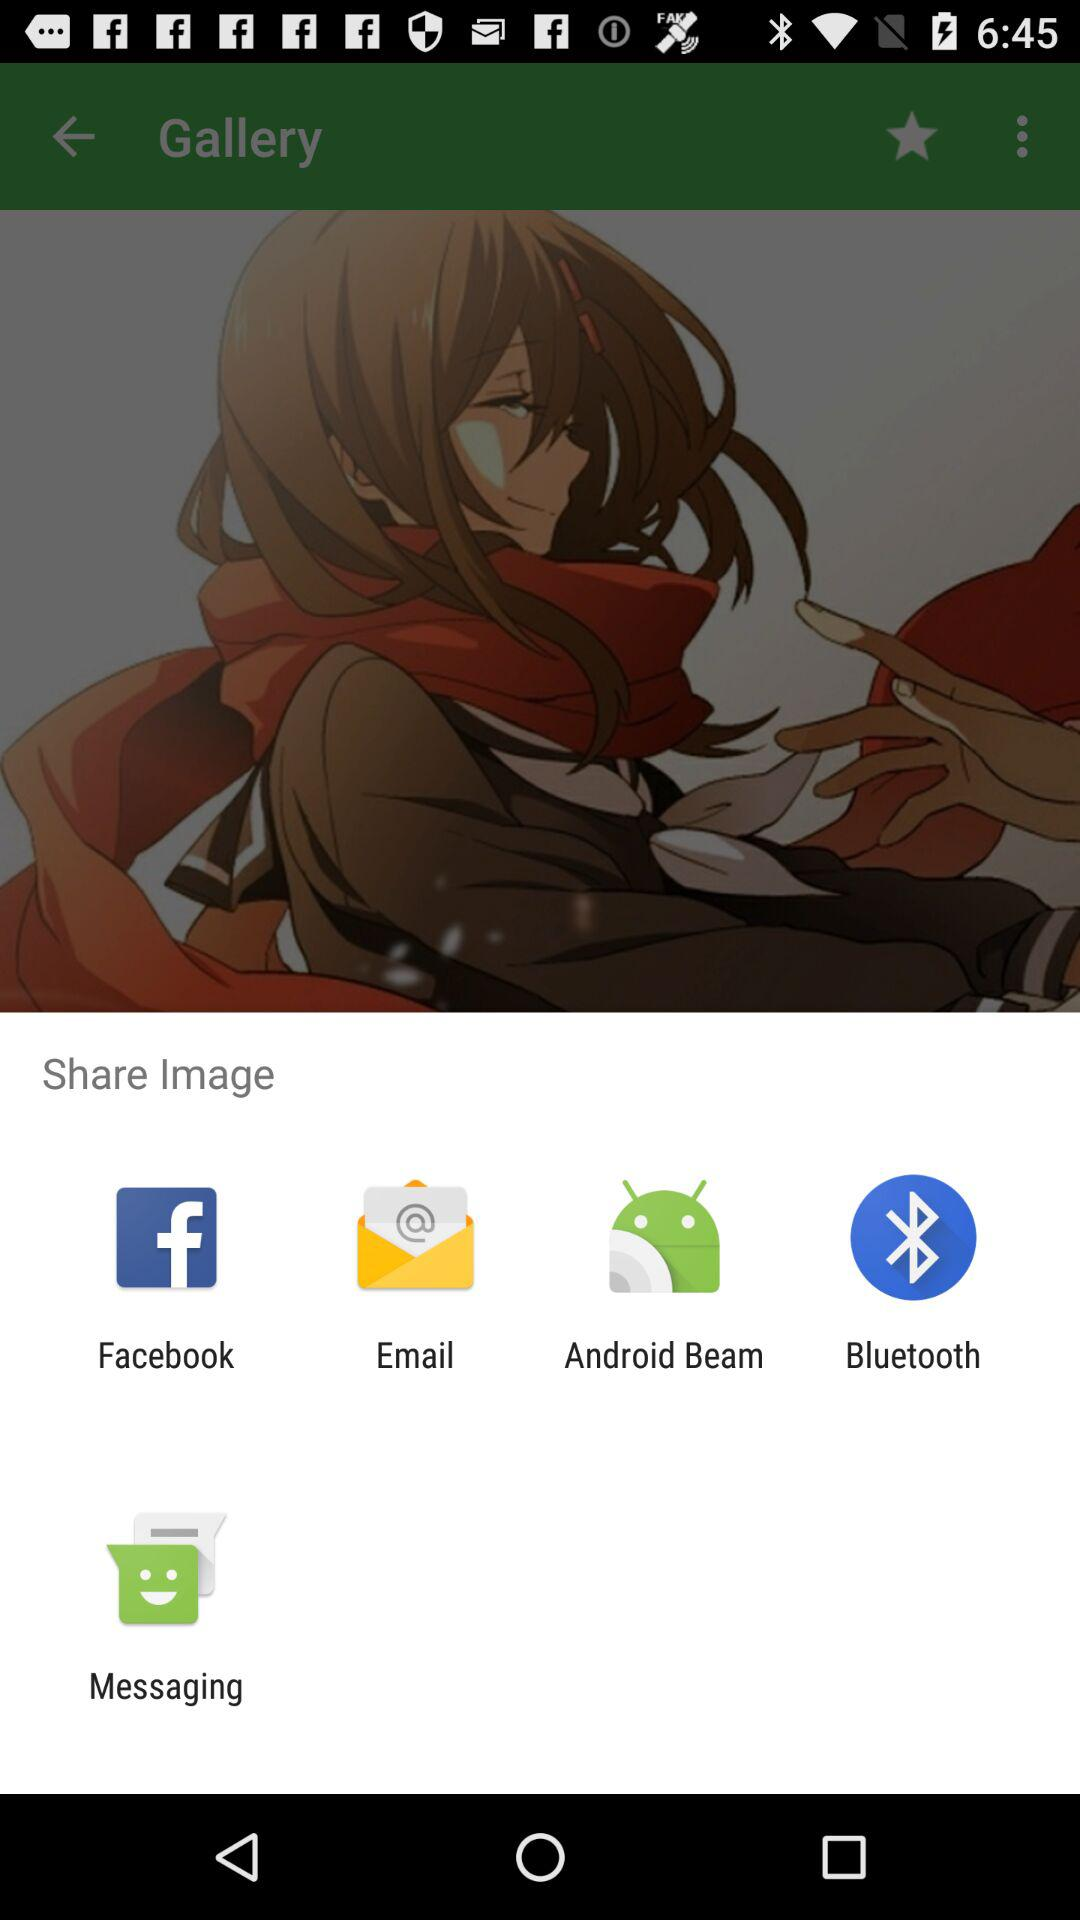Which sharing option is displayed first?
Answer the question using a single word or phrase. Facebook 